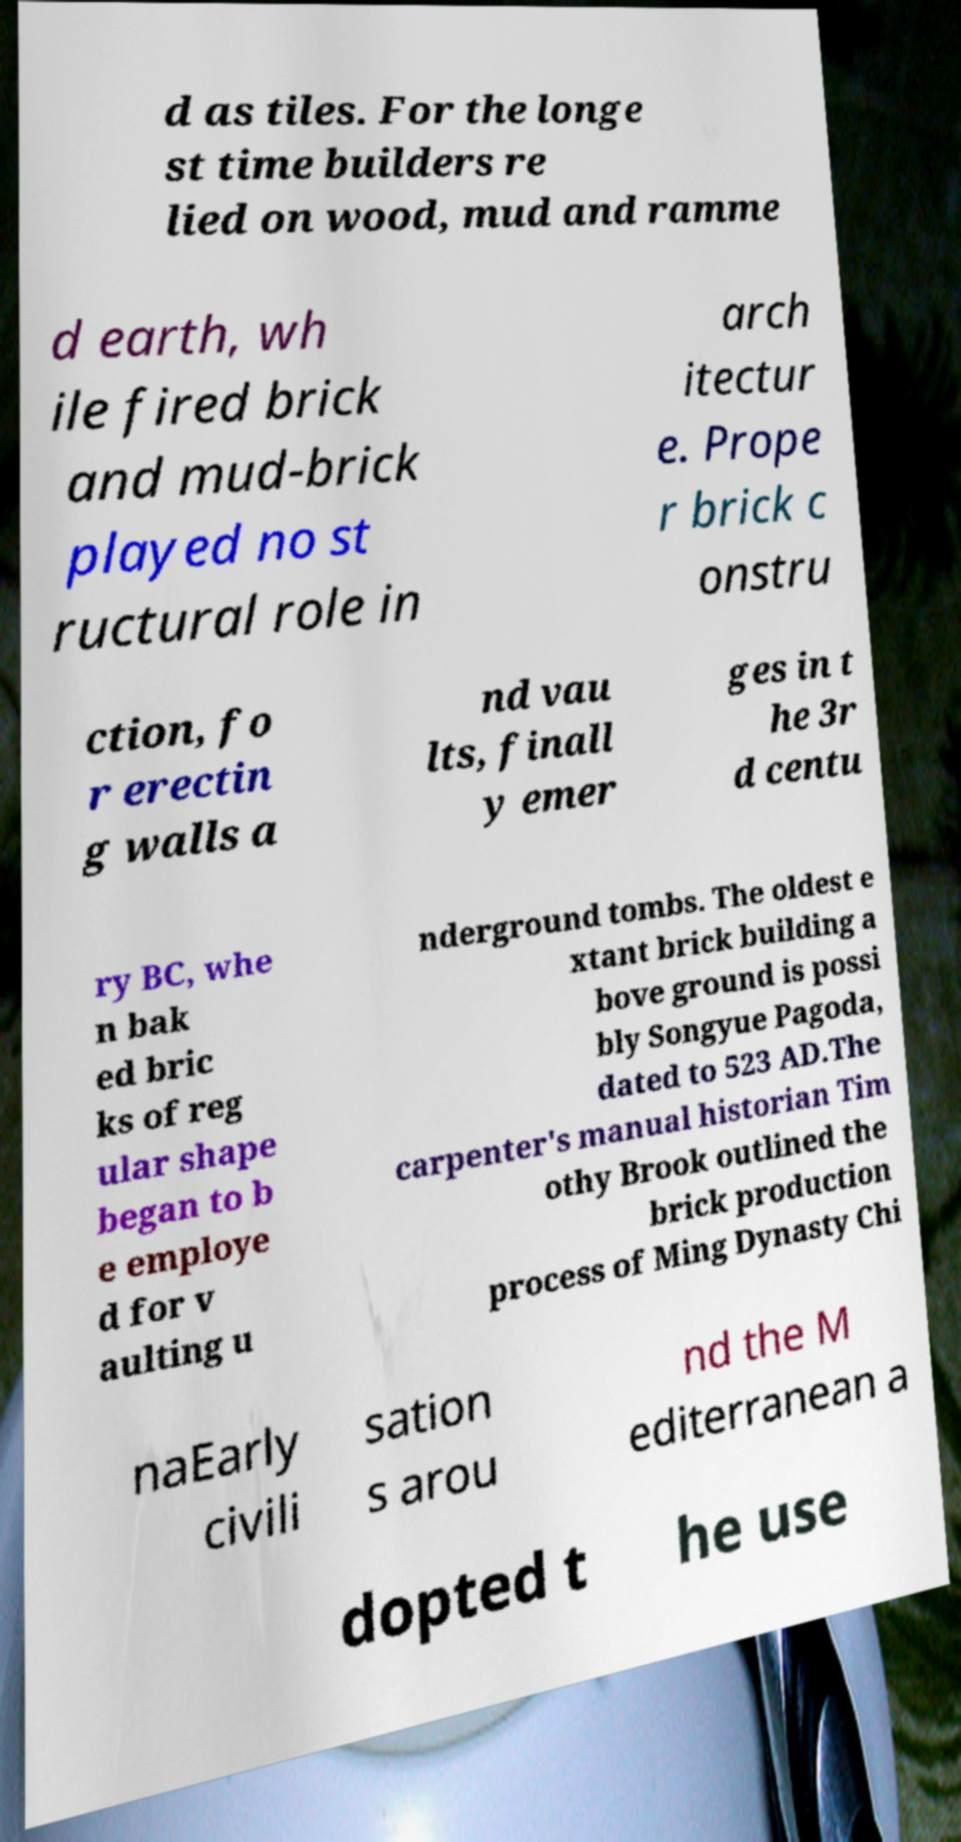Please identify and transcribe the text found in this image. d as tiles. For the longe st time builders re lied on wood, mud and ramme d earth, wh ile fired brick and mud-brick played no st ructural role in arch itectur e. Prope r brick c onstru ction, fo r erectin g walls a nd vau lts, finall y emer ges in t he 3r d centu ry BC, whe n bak ed bric ks of reg ular shape began to b e employe d for v aulting u nderground tombs. The oldest e xtant brick building a bove ground is possi bly Songyue Pagoda, dated to 523 AD.The carpenter's manual historian Tim othy Brook outlined the brick production process of Ming Dynasty Chi naEarly civili sation s arou nd the M editerranean a dopted t he use 